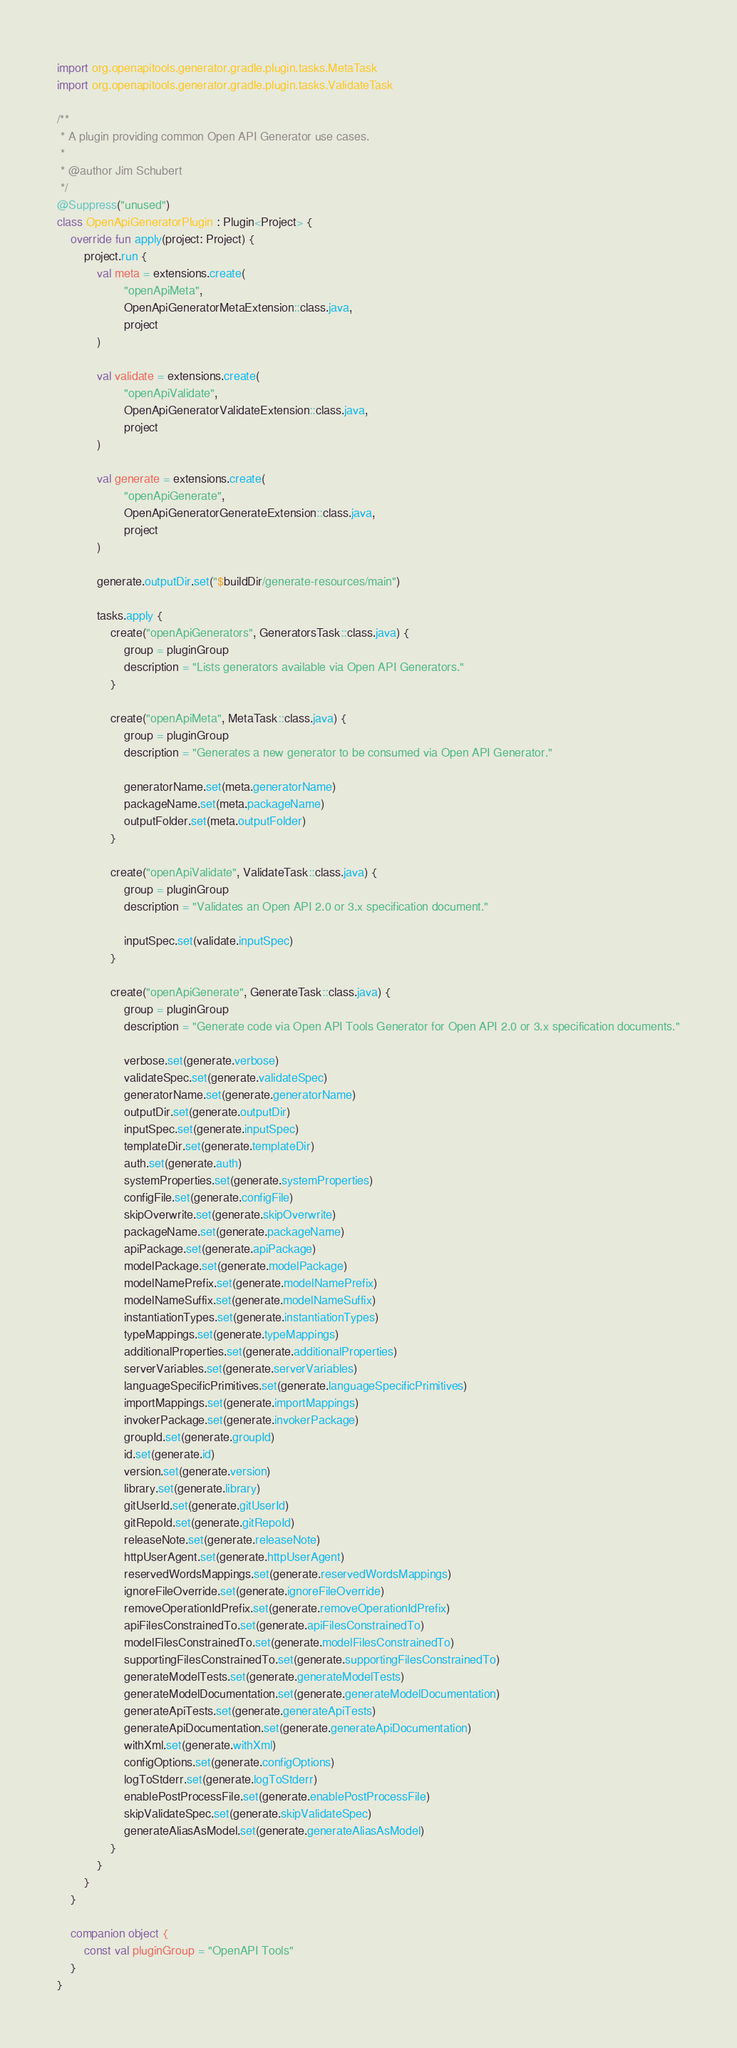Convert code to text. <code><loc_0><loc_0><loc_500><loc_500><_Kotlin_>import org.openapitools.generator.gradle.plugin.tasks.MetaTask
import org.openapitools.generator.gradle.plugin.tasks.ValidateTask

/**
 * A plugin providing common Open API Generator use cases.
 *
 * @author Jim Schubert
 */
@Suppress("unused")
class OpenApiGeneratorPlugin : Plugin<Project> {
    override fun apply(project: Project) {
        project.run {
            val meta = extensions.create(
                    "openApiMeta",
                    OpenApiGeneratorMetaExtension::class.java,
                    project
            )

            val validate = extensions.create(
                    "openApiValidate",
                    OpenApiGeneratorValidateExtension::class.java,
                    project
            )

            val generate = extensions.create(
                    "openApiGenerate",
                    OpenApiGeneratorGenerateExtension::class.java,
                    project
            )

            generate.outputDir.set("$buildDir/generate-resources/main")

            tasks.apply {
                create("openApiGenerators", GeneratorsTask::class.java) {
                    group = pluginGroup
                    description = "Lists generators available via Open API Generators."
                }

                create("openApiMeta", MetaTask::class.java) {
                    group = pluginGroup
                    description = "Generates a new generator to be consumed via Open API Generator."

                    generatorName.set(meta.generatorName)
                    packageName.set(meta.packageName)
                    outputFolder.set(meta.outputFolder)
                }

                create("openApiValidate", ValidateTask::class.java) {
                    group = pluginGroup
                    description = "Validates an Open API 2.0 or 3.x specification document."

                    inputSpec.set(validate.inputSpec)
                }

                create("openApiGenerate", GenerateTask::class.java) {
                    group = pluginGroup
                    description = "Generate code via Open API Tools Generator for Open API 2.0 or 3.x specification documents."

                    verbose.set(generate.verbose)
                    validateSpec.set(generate.validateSpec)
                    generatorName.set(generate.generatorName)
                    outputDir.set(generate.outputDir)
                    inputSpec.set(generate.inputSpec)
                    templateDir.set(generate.templateDir)
                    auth.set(generate.auth)
                    systemProperties.set(generate.systemProperties)
                    configFile.set(generate.configFile)
                    skipOverwrite.set(generate.skipOverwrite)
                    packageName.set(generate.packageName)
                    apiPackage.set(generate.apiPackage)
                    modelPackage.set(generate.modelPackage)
                    modelNamePrefix.set(generate.modelNamePrefix)
                    modelNameSuffix.set(generate.modelNameSuffix)
                    instantiationTypes.set(generate.instantiationTypes)
                    typeMappings.set(generate.typeMappings)
                    additionalProperties.set(generate.additionalProperties)
                    serverVariables.set(generate.serverVariables)
                    languageSpecificPrimitives.set(generate.languageSpecificPrimitives)
                    importMappings.set(generate.importMappings)
                    invokerPackage.set(generate.invokerPackage)
                    groupId.set(generate.groupId)
                    id.set(generate.id)
                    version.set(generate.version)
                    library.set(generate.library)
                    gitUserId.set(generate.gitUserId)
                    gitRepoId.set(generate.gitRepoId)
                    releaseNote.set(generate.releaseNote)
                    httpUserAgent.set(generate.httpUserAgent)
                    reservedWordsMappings.set(generate.reservedWordsMappings)
                    ignoreFileOverride.set(generate.ignoreFileOverride)
                    removeOperationIdPrefix.set(generate.removeOperationIdPrefix)
                    apiFilesConstrainedTo.set(generate.apiFilesConstrainedTo)
                    modelFilesConstrainedTo.set(generate.modelFilesConstrainedTo)
                    supportingFilesConstrainedTo.set(generate.supportingFilesConstrainedTo)
                    generateModelTests.set(generate.generateModelTests)
                    generateModelDocumentation.set(generate.generateModelDocumentation)
                    generateApiTests.set(generate.generateApiTests)
                    generateApiDocumentation.set(generate.generateApiDocumentation)
                    withXml.set(generate.withXml)
                    configOptions.set(generate.configOptions)
                    logToStderr.set(generate.logToStderr)
                    enablePostProcessFile.set(generate.enablePostProcessFile)
                    skipValidateSpec.set(generate.skipValidateSpec)
                    generateAliasAsModel.set(generate.generateAliasAsModel)
                }
            }
        }
    }

    companion object {
        const val pluginGroup = "OpenAPI Tools"
    }
}

</code> 